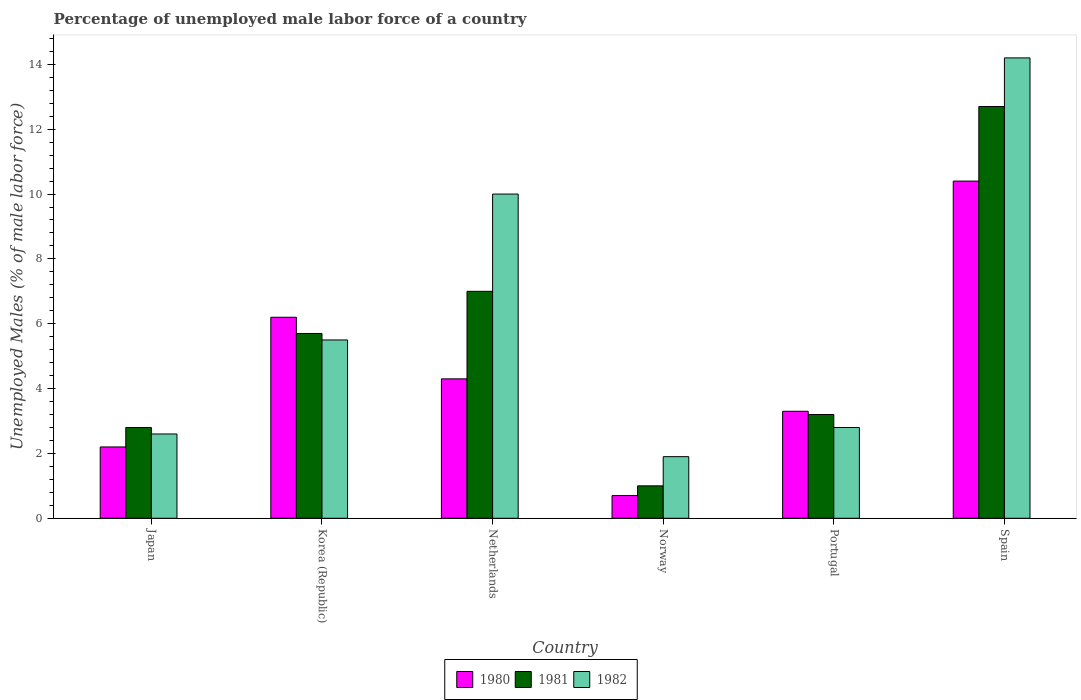How many different coloured bars are there?
Ensure brevity in your answer.  3. How many bars are there on the 5th tick from the left?
Keep it short and to the point. 3. What is the label of the 2nd group of bars from the left?
Your response must be concise. Korea (Republic). In how many cases, is the number of bars for a given country not equal to the number of legend labels?
Keep it short and to the point. 0. What is the percentage of unemployed male labor force in 1980 in Portugal?
Provide a succinct answer. 3.3. Across all countries, what is the maximum percentage of unemployed male labor force in 1981?
Make the answer very short. 12.7. Across all countries, what is the minimum percentage of unemployed male labor force in 1982?
Offer a terse response. 1.9. In which country was the percentage of unemployed male labor force in 1982 maximum?
Offer a very short reply. Spain. What is the total percentage of unemployed male labor force in 1982 in the graph?
Your response must be concise. 37. What is the difference between the percentage of unemployed male labor force in 1980 in Netherlands and that in Norway?
Offer a terse response. 3.6. What is the difference between the percentage of unemployed male labor force in 1981 in Portugal and the percentage of unemployed male labor force in 1980 in Korea (Republic)?
Provide a succinct answer. -3. What is the average percentage of unemployed male labor force in 1982 per country?
Ensure brevity in your answer.  6.17. What is the difference between the percentage of unemployed male labor force of/in 1982 and percentage of unemployed male labor force of/in 1981 in Korea (Republic)?
Give a very brief answer. -0.2. In how many countries, is the percentage of unemployed male labor force in 1980 greater than 10.4 %?
Offer a terse response. 0. What is the ratio of the percentage of unemployed male labor force in 1980 in Netherlands to that in Norway?
Offer a terse response. 6.14. Is the percentage of unemployed male labor force in 1981 in Japan less than that in Spain?
Ensure brevity in your answer.  Yes. Is the difference between the percentage of unemployed male labor force in 1982 in Korea (Republic) and Netherlands greater than the difference between the percentage of unemployed male labor force in 1981 in Korea (Republic) and Netherlands?
Provide a succinct answer. No. What is the difference between the highest and the lowest percentage of unemployed male labor force in 1980?
Give a very brief answer. 9.7. Is the sum of the percentage of unemployed male labor force in 1980 in Netherlands and Portugal greater than the maximum percentage of unemployed male labor force in 1982 across all countries?
Offer a very short reply. No. Is it the case that in every country, the sum of the percentage of unemployed male labor force in 1982 and percentage of unemployed male labor force in 1981 is greater than the percentage of unemployed male labor force in 1980?
Offer a very short reply. Yes. Are all the bars in the graph horizontal?
Your answer should be compact. No. What is the difference between two consecutive major ticks on the Y-axis?
Keep it short and to the point. 2. Does the graph contain grids?
Provide a short and direct response. No. How many legend labels are there?
Provide a succinct answer. 3. What is the title of the graph?
Keep it short and to the point. Percentage of unemployed male labor force of a country. What is the label or title of the Y-axis?
Offer a terse response. Unemployed Males (% of male labor force). What is the Unemployed Males (% of male labor force) of 1980 in Japan?
Your answer should be compact. 2.2. What is the Unemployed Males (% of male labor force) of 1981 in Japan?
Your answer should be compact. 2.8. What is the Unemployed Males (% of male labor force) in 1982 in Japan?
Your answer should be very brief. 2.6. What is the Unemployed Males (% of male labor force) in 1980 in Korea (Republic)?
Offer a very short reply. 6.2. What is the Unemployed Males (% of male labor force) of 1981 in Korea (Republic)?
Make the answer very short. 5.7. What is the Unemployed Males (% of male labor force) in 1982 in Korea (Republic)?
Provide a short and direct response. 5.5. What is the Unemployed Males (% of male labor force) of 1980 in Netherlands?
Keep it short and to the point. 4.3. What is the Unemployed Males (% of male labor force) in 1981 in Netherlands?
Your answer should be very brief. 7. What is the Unemployed Males (% of male labor force) in 1980 in Norway?
Provide a short and direct response. 0.7. What is the Unemployed Males (% of male labor force) in 1981 in Norway?
Make the answer very short. 1. What is the Unemployed Males (% of male labor force) in 1982 in Norway?
Your answer should be compact. 1.9. What is the Unemployed Males (% of male labor force) of 1980 in Portugal?
Make the answer very short. 3.3. What is the Unemployed Males (% of male labor force) of 1981 in Portugal?
Your answer should be compact. 3.2. What is the Unemployed Males (% of male labor force) of 1982 in Portugal?
Ensure brevity in your answer.  2.8. What is the Unemployed Males (% of male labor force) of 1980 in Spain?
Your answer should be compact. 10.4. What is the Unemployed Males (% of male labor force) of 1981 in Spain?
Provide a short and direct response. 12.7. What is the Unemployed Males (% of male labor force) in 1982 in Spain?
Offer a very short reply. 14.2. Across all countries, what is the maximum Unemployed Males (% of male labor force) in 1980?
Your answer should be very brief. 10.4. Across all countries, what is the maximum Unemployed Males (% of male labor force) of 1981?
Provide a succinct answer. 12.7. Across all countries, what is the maximum Unemployed Males (% of male labor force) of 1982?
Offer a very short reply. 14.2. Across all countries, what is the minimum Unemployed Males (% of male labor force) of 1980?
Provide a short and direct response. 0.7. Across all countries, what is the minimum Unemployed Males (% of male labor force) of 1982?
Your answer should be very brief. 1.9. What is the total Unemployed Males (% of male labor force) in 1980 in the graph?
Offer a terse response. 27.1. What is the total Unemployed Males (% of male labor force) of 1981 in the graph?
Keep it short and to the point. 32.4. What is the difference between the Unemployed Males (% of male labor force) in 1981 in Japan and that in Korea (Republic)?
Your response must be concise. -2.9. What is the difference between the Unemployed Males (% of male labor force) of 1980 in Japan and that in Netherlands?
Your answer should be very brief. -2.1. What is the difference between the Unemployed Males (% of male labor force) in 1981 in Japan and that in Netherlands?
Provide a succinct answer. -4.2. What is the difference between the Unemployed Males (% of male labor force) of 1982 in Japan and that in Norway?
Give a very brief answer. 0.7. What is the difference between the Unemployed Males (% of male labor force) in 1980 in Japan and that in Spain?
Keep it short and to the point. -8.2. What is the difference between the Unemployed Males (% of male labor force) in 1982 in Japan and that in Spain?
Offer a very short reply. -11.6. What is the difference between the Unemployed Males (% of male labor force) of 1980 in Korea (Republic) and that in Netherlands?
Offer a very short reply. 1.9. What is the difference between the Unemployed Males (% of male labor force) of 1981 in Korea (Republic) and that in Netherlands?
Your answer should be very brief. -1.3. What is the difference between the Unemployed Males (% of male labor force) of 1982 in Korea (Republic) and that in Netherlands?
Make the answer very short. -4.5. What is the difference between the Unemployed Males (% of male labor force) of 1980 in Korea (Republic) and that in Norway?
Offer a very short reply. 5.5. What is the difference between the Unemployed Males (% of male labor force) in 1981 in Korea (Republic) and that in Norway?
Ensure brevity in your answer.  4.7. What is the difference between the Unemployed Males (% of male labor force) in 1982 in Korea (Republic) and that in Norway?
Offer a very short reply. 3.6. What is the difference between the Unemployed Males (% of male labor force) of 1980 in Korea (Republic) and that in Portugal?
Provide a succinct answer. 2.9. What is the difference between the Unemployed Males (% of male labor force) in 1981 in Korea (Republic) and that in Portugal?
Offer a terse response. 2.5. What is the difference between the Unemployed Males (% of male labor force) of 1982 in Korea (Republic) and that in Portugal?
Provide a succinct answer. 2.7. What is the difference between the Unemployed Males (% of male labor force) of 1981 in Netherlands and that in Norway?
Your response must be concise. 6. What is the difference between the Unemployed Males (% of male labor force) of 1982 in Netherlands and that in Norway?
Provide a short and direct response. 8.1. What is the difference between the Unemployed Males (% of male labor force) in 1981 in Netherlands and that in Portugal?
Provide a short and direct response. 3.8. What is the difference between the Unemployed Males (% of male labor force) of 1980 in Netherlands and that in Spain?
Your answer should be very brief. -6.1. What is the difference between the Unemployed Males (% of male labor force) of 1982 in Netherlands and that in Spain?
Offer a terse response. -4.2. What is the difference between the Unemployed Males (% of male labor force) of 1981 in Norway and that in Portugal?
Your response must be concise. -2.2. What is the difference between the Unemployed Males (% of male labor force) in 1982 in Norway and that in Portugal?
Ensure brevity in your answer.  -0.9. What is the difference between the Unemployed Males (% of male labor force) in 1980 in Norway and that in Spain?
Your response must be concise. -9.7. What is the difference between the Unemployed Males (% of male labor force) of 1980 in Portugal and that in Spain?
Keep it short and to the point. -7.1. What is the difference between the Unemployed Males (% of male labor force) of 1982 in Portugal and that in Spain?
Provide a short and direct response. -11.4. What is the difference between the Unemployed Males (% of male labor force) in 1980 in Japan and the Unemployed Males (% of male labor force) in 1981 in Norway?
Offer a terse response. 1.2. What is the difference between the Unemployed Males (% of male labor force) in 1980 in Japan and the Unemployed Males (% of male labor force) in 1982 in Portugal?
Provide a succinct answer. -0.6. What is the difference between the Unemployed Males (% of male labor force) of 1980 in Korea (Republic) and the Unemployed Males (% of male labor force) of 1981 in Netherlands?
Your response must be concise. -0.8. What is the difference between the Unemployed Males (% of male labor force) of 1980 in Korea (Republic) and the Unemployed Males (% of male labor force) of 1982 in Netherlands?
Your response must be concise. -3.8. What is the difference between the Unemployed Males (% of male labor force) in 1980 in Korea (Republic) and the Unemployed Males (% of male labor force) in 1981 in Norway?
Provide a short and direct response. 5.2. What is the difference between the Unemployed Males (% of male labor force) in 1981 in Korea (Republic) and the Unemployed Males (% of male labor force) in 1982 in Portugal?
Give a very brief answer. 2.9. What is the difference between the Unemployed Males (% of male labor force) in 1980 in Netherlands and the Unemployed Males (% of male labor force) in 1981 in Norway?
Make the answer very short. 3.3. What is the difference between the Unemployed Males (% of male labor force) in 1980 in Netherlands and the Unemployed Males (% of male labor force) in 1982 in Norway?
Offer a terse response. 2.4. What is the difference between the Unemployed Males (% of male labor force) of 1981 in Netherlands and the Unemployed Males (% of male labor force) of 1982 in Norway?
Offer a terse response. 5.1. What is the difference between the Unemployed Males (% of male labor force) in 1980 in Netherlands and the Unemployed Males (% of male labor force) in 1982 in Portugal?
Provide a succinct answer. 1.5. What is the difference between the Unemployed Males (% of male labor force) in 1981 in Netherlands and the Unemployed Males (% of male labor force) in 1982 in Spain?
Ensure brevity in your answer.  -7.2. What is the difference between the Unemployed Males (% of male labor force) in 1980 in Norway and the Unemployed Males (% of male labor force) in 1981 in Portugal?
Make the answer very short. -2.5. What is the difference between the Unemployed Males (% of male labor force) in 1980 in Norway and the Unemployed Males (% of male labor force) in 1981 in Spain?
Keep it short and to the point. -12. What is the difference between the Unemployed Males (% of male labor force) in 1981 in Norway and the Unemployed Males (% of male labor force) in 1982 in Spain?
Keep it short and to the point. -13.2. What is the difference between the Unemployed Males (% of male labor force) in 1980 in Portugal and the Unemployed Males (% of male labor force) in 1981 in Spain?
Offer a terse response. -9.4. What is the difference between the Unemployed Males (% of male labor force) in 1980 in Portugal and the Unemployed Males (% of male labor force) in 1982 in Spain?
Your answer should be very brief. -10.9. What is the average Unemployed Males (% of male labor force) in 1980 per country?
Provide a short and direct response. 4.52. What is the average Unemployed Males (% of male labor force) in 1982 per country?
Give a very brief answer. 6.17. What is the difference between the Unemployed Males (% of male labor force) in 1980 and Unemployed Males (% of male labor force) in 1981 in Japan?
Provide a short and direct response. -0.6. What is the difference between the Unemployed Males (% of male labor force) in 1981 and Unemployed Males (% of male labor force) in 1982 in Japan?
Give a very brief answer. 0.2. What is the difference between the Unemployed Males (% of male labor force) in 1980 and Unemployed Males (% of male labor force) in 1981 in Korea (Republic)?
Provide a short and direct response. 0.5. What is the difference between the Unemployed Males (% of male labor force) in 1980 and Unemployed Males (% of male labor force) in 1981 in Netherlands?
Give a very brief answer. -2.7. What is the difference between the Unemployed Males (% of male labor force) of 1980 and Unemployed Males (% of male labor force) of 1982 in Netherlands?
Your response must be concise. -5.7. What is the difference between the Unemployed Males (% of male labor force) in 1980 and Unemployed Males (% of male labor force) in 1981 in Norway?
Keep it short and to the point. -0.3. What is the difference between the Unemployed Males (% of male labor force) of 1980 and Unemployed Males (% of male labor force) of 1981 in Portugal?
Your response must be concise. 0.1. What is the difference between the Unemployed Males (% of male labor force) in 1981 and Unemployed Males (% of male labor force) in 1982 in Portugal?
Keep it short and to the point. 0.4. What is the difference between the Unemployed Males (% of male labor force) of 1980 and Unemployed Males (% of male labor force) of 1981 in Spain?
Make the answer very short. -2.3. What is the ratio of the Unemployed Males (% of male labor force) in 1980 in Japan to that in Korea (Republic)?
Provide a short and direct response. 0.35. What is the ratio of the Unemployed Males (% of male labor force) of 1981 in Japan to that in Korea (Republic)?
Offer a very short reply. 0.49. What is the ratio of the Unemployed Males (% of male labor force) of 1982 in Japan to that in Korea (Republic)?
Give a very brief answer. 0.47. What is the ratio of the Unemployed Males (% of male labor force) in 1980 in Japan to that in Netherlands?
Provide a succinct answer. 0.51. What is the ratio of the Unemployed Males (% of male labor force) of 1981 in Japan to that in Netherlands?
Offer a very short reply. 0.4. What is the ratio of the Unemployed Males (% of male labor force) in 1982 in Japan to that in Netherlands?
Make the answer very short. 0.26. What is the ratio of the Unemployed Males (% of male labor force) in 1980 in Japan to that in Norway?
Provide a succinct answer. 3.14. What is the ratio of the Unemployed Males (% of male labor force) in 1981 in Japan to that in Norway?
Give a very brief answer. 2.8. What is the ratio of the Unemployed Males (% of male labor force) of 1982 in Japan to that in Norway?
Your answer should be compact. 1.37. What is the ratio of the Unemployed Males (% of male labor force) of 1982 in Japan to that in Portugal?
Provide a succinct answer. 0.93. What is the ratio of the Unemployed Males (% of male labor force) of 1980 in Japan to that in Spain?
Your answer should be very brief. 0.21. What is the ratio of the Unemployed Males (% of male labor force) of 1981 in Japan to that in Spain?
Your response must be concise. 0.22. What is the ratio of the Unemployed Males (% of male labor force) in 1982 in Japan to that in Spain?
Provide a succinct answer. 0.18. What is the ratio of the Unemployed Males (% of male labor force) in 1980 in Korea (Republic) to that in Netherlands?
Give a very brief answer. 1.44. What is the ratio of the Unemployed Males (% of male labor force) of 1981 in Korea (Republic) to that in Netherlands?
Your answer should be very brief. 0.81. What is the ratio of the Unemployed Males (% of male labor force) in 1982 in Korea (Republic) to that in Netherlands?
Your answer should be very brief. 0.55. What is the ratio of the Unemployed Males (% of male labor force) of 1980 in Korea (Republic) to that in Norway?
Offer a very short reply. 8.86. What is the ratio of the Unemployed Males (% of male labor force) of 1982 in Korea (Republic) to that in Norway?
Give a very brief answer. 2.89. What is the ratio of the Unemployed Males (% of male labor force) of 1980 in Korea (Republic) to that in Portugal?
Your answer should be very brief. 1.88. What is the ratio of the Unemployed Males (% of male labor force) in 1981 in Korea (Republic) to that in Portugal?
Provide a short and direct response. 1.78. What is the ratio of the Unemployed Males (% of male labor force) in 1982 in Korea (Republic) to that in Portugal?
Your response must be concise. 1.96. What is the ratio of the Unemployed Males (% of male labor force) of 1980 in Korea (Republic) to that in Spain?
Provide a short and direct response. 0.6. What is the ratio of the Unemployed Males (% of male labor force) in 1981 in Korea (Republic) to that in Spain?
Give a very brief answer. 0.45. What is the ratio of the Unemployed Males (% of male labor force) of 1982 in Korea (Republic) to that in Spain?
Your answer should be very brief. 0.39. What is the ratio of the Unemployed Males (% of male labor force) of 1980 in Netherlands to that in Norway?
Give a very brief answer. 6.14. What is the ratio of the Unemployed Males (% of male labor force) in 1981 in Netherlands to that in Norway?
Give a very brief answer. 7. What is the ratio of the Unemployed Males (% of male labor force) in 1982 in Netherlands to that in Norway?
Give a very brief answer. 5.26. What is the ratio of the Unemployed Males (% of male labor force) in 1980 in Netherlands to that in Portugal?
Make the answer very short. 1.3. What is the ratio of the Unemployed Males (% of male labor force) of 1981 in Netherlands to that in Portugal?
Your answer should be compact. 2.19. What is the ratio of the Unemployed Males (% of male labor force) in 1982 in Netherlands to that in Portugal?
Offer a very short reply. 3.57. What is the ratio of the Unemployed Males (% of male labor force) of 1980 in Netherlands to that in Spain?
Your answer should be compact. 0.41. What is the ratio of the Unemployed Males (% of male labor force) in 1981 in Netherlands to that in Spain?
Offer a terse response. 0.55. What is the ratio of the Unemployed Males (% of male labor force) of 1982 in Netherlands to that in Spain?
Your answer should be very brief. 0.7. What is the ratio of the Unemployed Males (% of male labor force) in 1980 in Norway to that in Portugal?
Make the answer very short. 0.21. What is the ratio of the Unemployed Males (% of male labor force) of 1981 in Norway to that in Portugal?
Provide a short and direct response. 0.31. What is the ratio of the Unemployed Males (% of male labor force) of 1982 in Norway to that in Portugal?
Give a very brief answer. 0.68. What is the ratio of the Unemployed Males (% of male labor force) of 1980 in Norway to that in Spain?
Keep it short and to the point. 0.07. What is the ratio of the Unemployed Males (% of male labor force) in 1981 in Norway to that in Spain?
Provide a succinct answer. 0.08. What is the ratio of the Unemployed Males (% of male labor force) of 1982 in Norway to that in Spain?
Offer a terse response. 0.13. What is the ratio of the Unemployed Males (% of male labor force) of 1980 in Portugal to that in Spain?
Give a very brief answer. 0.32. What is the ratio of the Unemployed Males (% of male labor force) of 1981 in Portugal to that in Spain?
Keep it short and to the point. 0.25. What is the ratio of the Unemployed Males (% of male labor force) of 1982 in Portugal to that in Spain?
Offer a very short reply. 0.2. What is the difference between the highest and the second highest Unemployed Males (% of male labor force) of 1980?
Your answer should be very brief. 4.2. What is the difference between the highest and the second highest Unemployed Males (% of male labor force) of 1982?
Your answer should be very brief. 4.2. What is the difference between the highest and the lowest Unemployed Males (% of male labor force) of 1980?
Offer a terse response. 9.7. What is the difference between the highest and the lowest Unemployed Males (% of male labor force) of 1981?
Provide a succinct answer. 11.7. 